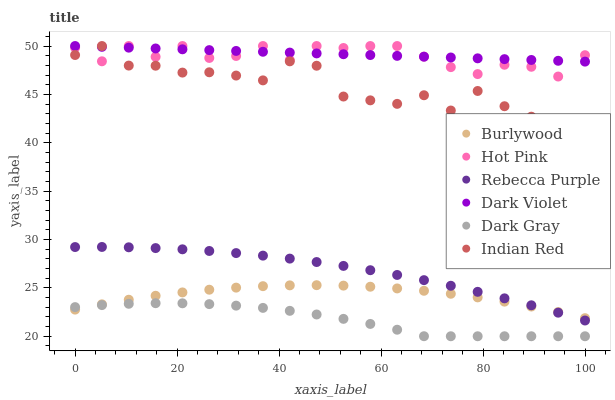Does Dark Gray have the minimum area under the curve?
Answer yes or no. Yes. Does Dark Violet have the maximum area under the curve?
Answer yes or no. Yes. Does Hot Pink have the minimum area under the curve?
Answer yes or no. No. Does Hot Pink have the maximum area under the curve?
Answer yes or no. No. Is Dark Violet the smoothest?
Answer yes or no. Yes. Is Indian Red the roughest?
Answer yes or no. Yes. Is Hot Pink the smoothest?
Answer yes or no. No. Is Hot Pink the roughest?
Answer yes or no. No. Does Dark Gray have the lowest value?
Answer yes or no. Yes. Does Hot Pink have the lowest value?
Answer yes or no. No. Does Indian Red have the highest value?
Answer yes or no. Yes. Does Dark Gray have the highest value?
Answer yes or no. No. Is Dark Gray less than Indian Red?
Answer yes or no. Yes. Is Rebecca Purple greater than Dark Gray?
Answer yes or no. Yes. Does Burlywood intersect Dark Gray?
Answer yes or no. Yes. Is Burlywood less than Dark Gray?
Answer yes or no. No. Is Burlywood greater than Dark Gray?
Answer yes or no. No. Does Dark Gray intersect Indian Red?
Answer yes or no. No. 